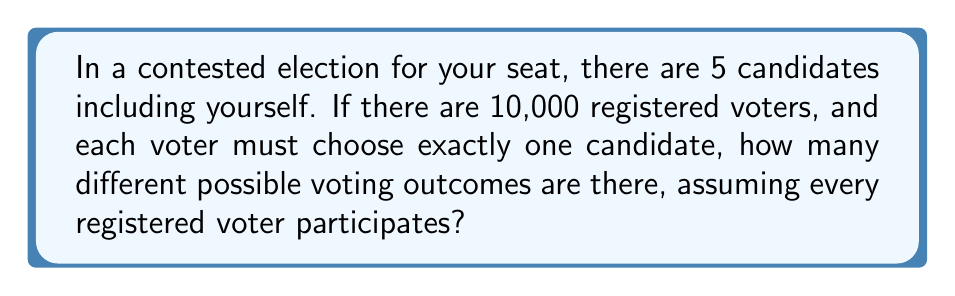Can you answer this question? Let's approach this step-by-step:

1) First, we need to understand what the question is asking. We're looking for the total number of ways the votes can be distributed among the 5 candidates.

2) This is a classic example of a combination with repetition problem. Each voter has 5 choices, and their choice is independent of other voters.

3) In combinatorics, this scenario is represented by the formula:

   $$ n^r $$

   Where $n$ is the number of choices for each event (in this case, the number of candidates), and $r$ is the number of events (in this case, the number of voters).

4) In our problem:
   $n = 5$ (number of candidates)
   $r = 10,000$ (number of voters)

5) Therefore, the number of possible voting outcomes is:

   $$ 5^{10,000} $$

6) This is an extremely large number. To give some perspective:
   
   $$ 5^{10,000} \approx 9.5 \times 10^{6989} $$

   This number is so large that it's difficult to comprehend. It's much larger than the number of atoms in the observable universe!
Answer: $5^{10,000}$ 